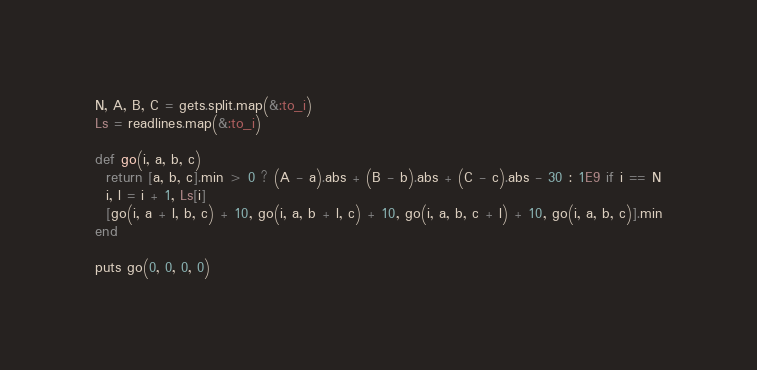Convert code to text. <code><loc_0><loc_0><loc_500><loc_500><_Ruby_>N, A, B, C = gets.split.map(&:to_i)
Ls = readlines.map(&:to_i)

def go(i, a, b, c)
  return [a, b, c].min > 0 ? (A - a).abs + (B - b).abs + (C - c).abs - 30 : 1E9 if i == N
  i, l = i + 1, Ls[i]
  [go(i, a + l, b, c) + 10, go(i, a, b + l, c) + 10, go(i, a, b, c + l) + 10, go(i, a, b, c)].min
end

puts go(0, 0, 0, 0)</code> 